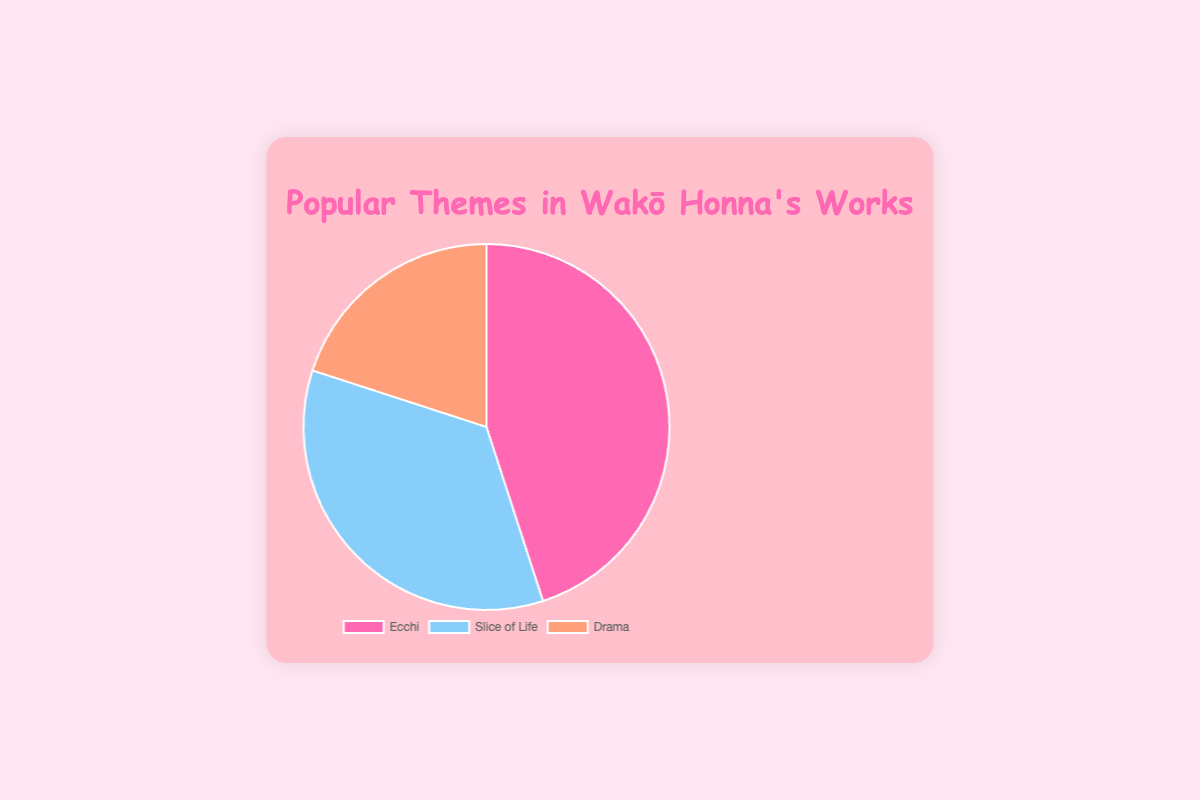What is the most popular theme in Wakō Honna's works? The pie chart shows three themes: Ecchi, Slice of Life, and Drama, with their respective percentages. The largest segment represents the most popular theme.
Answer: Ecchi What percentage of themes in Wakō Honna's works relate to Ecchi? The chart has a segment labeled 'Ecchi' with a corresponding percentage.
Answer: 45% Which theme has a larger percentage: Slice of Life or Drama? By comparing the segments, Slice of Life and Drama, we can see which has a larger segment based on their percentages.
Answer: Slice of Life What is the combined percentage of Slice of Life and Drama themes? Add the percentages of Slice of Life (35%) and Drama (20%) from the chart. 35% + 20% = 55%
Answer: 55% How much larger is the percentage for Ecchi compared to Drama? Subtract the percentage of Drama (20%) from the percentage of Ecchi (45%). 45% - 20% = 25%
Answer: 25% Which theme is represented by the blue segment in the pie chart? Identify the colors associated with each segment and find the segment colored blue.
Answer: Slice of Life If you combine the percent of Ecchi and Slice of Life, what fraction of the whole do they represent? Add the percentages of Ecchi (45%) and Slice of Life (35%). Then express it as a fraction: (45 + 35)/100 = 80/100 simplifies to 4/5.
Answer: 4/5 Rank the themes from most to least popular based on their percentages. Order the themes by their respective percentages from highest to lowest: Ecchi (45%), Slice of Life (35%), Drama (20%).
Answer: Ecchi, Slice of Life, Drama What percentage of the themes are not Drama? Subtract the percentage of Drama (20%) from 100%. 100% - 20% = 80%
Answer: 80% Which two themes together make up less than 60% of the total? Check the combinations of two themes and ensure their total is less than 60%. Slice of Life (35%) + Drama (20%) = 55%.
Answer: Slice of Life and Drama 